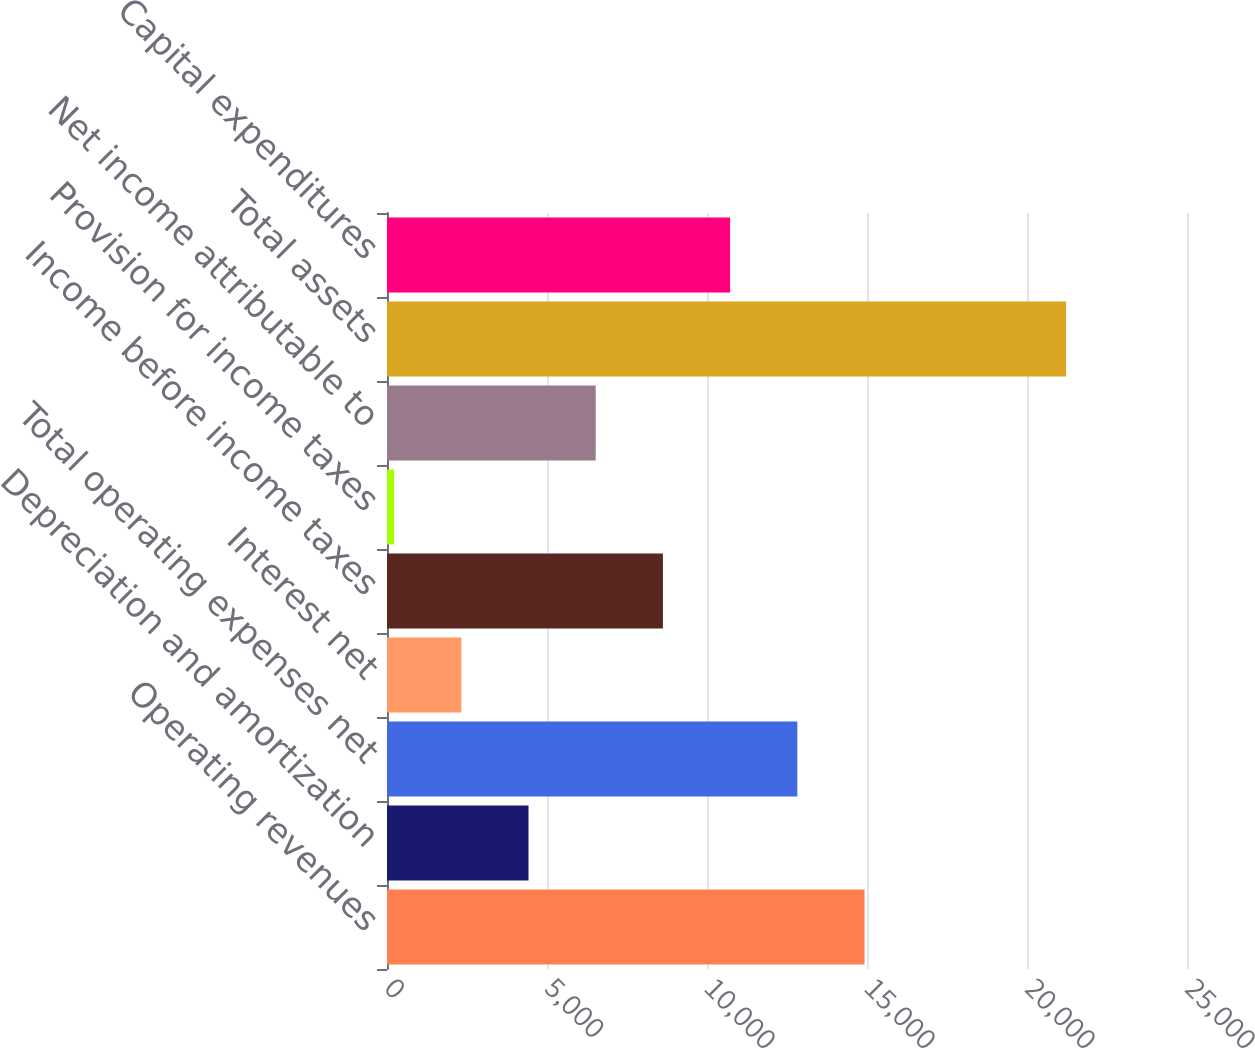Convert chart to OTSL. <chart><loc_0><loc_0><loc_500><loc_500><bar_chart><fcel>Operating revenues<fcel>Depreciation and amortization<fcel>Total operating expenses net<fcel>Interest net<fcel>Income before income taxes<fcel>Provision for income taxes<fcel>Net income attributable to<fcel>Total assets<fcel>Capital expenditures<nl><fcel>14922.7<fcel>4422.2<fcel>12822.6<fcel>2322.1<fcel>8622.4<fcel>222<fcel>6522.3<fcel>21223<fcel>10722.5<nl></chart> 